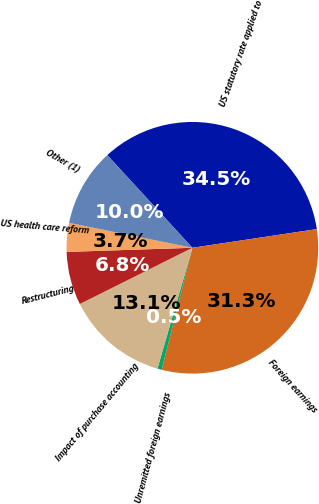<chart> <loc_0><loc_0><loc_500><loc_500><pie_chart><fcel>US statutory rate applied to<fcel>Foreign earnings<fcel>Unremitted foreign earnings<fcel>Impact of purchase accounting<fcel>Restructuring<fcel>US health care reform<fcel>Other (1)<nl><fcel>34.46%<fcel>31.31%<fcel>0.55%<fcel>13.15%<fcel>6.85%<fcel>3.7%<fcel>10.0%<nl></chart> 